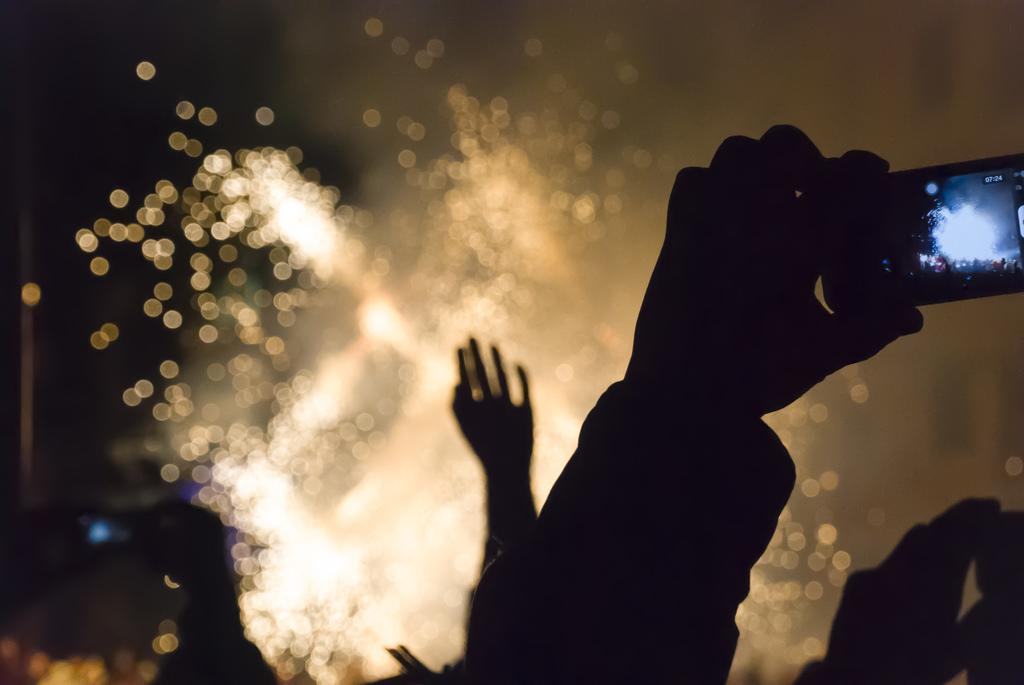How many people are in the image? There are persons in the image, but the exact number is not specified. What is a person doing with their hand in the image? A person's hand is holding a mobile phone in the front of the image. Can you describe the background of the image? The background of the image is blurry. What type of mine is visible in the background of the image? There is no mine present in the image; the background is blurry, but no specific structures or objects are mentioned. How many pets are visible in the image? There is no mention of pets in the image, so it is impossible to determine their presence or number. 